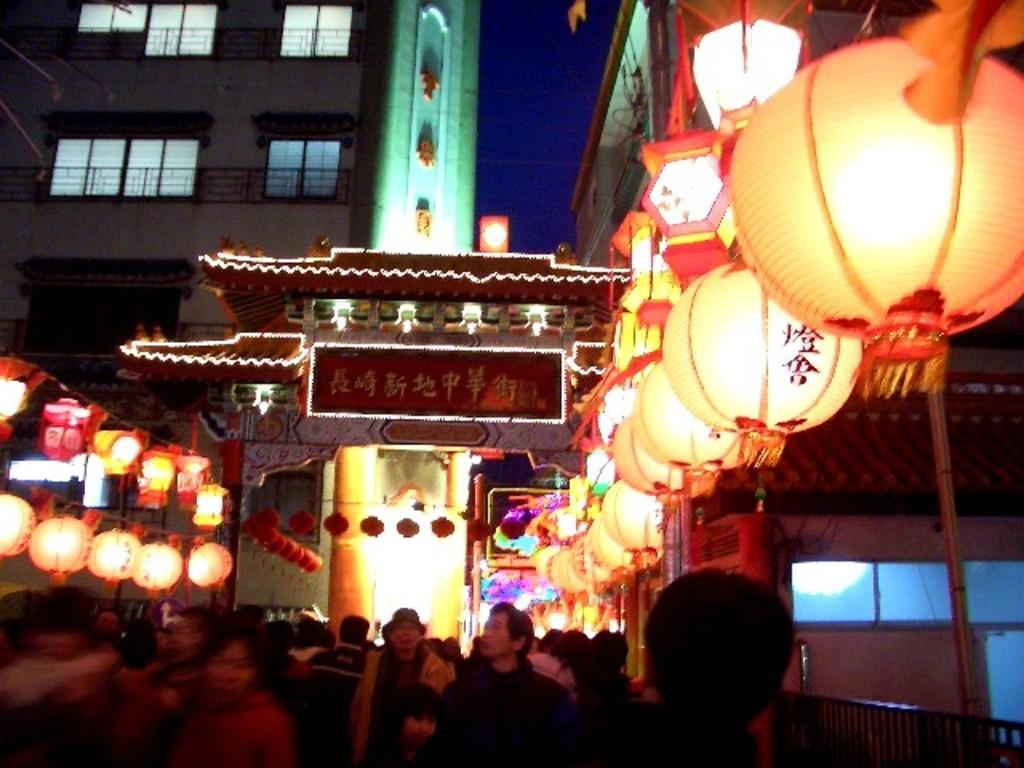What type of structures can be seen in the image? There are buildings in the image. Are there any people present in the image? Yes, there are people standing in the image. What type of lighting is present in the image? There are lanterns and an arch with lighting in the image. Where is the kettle located in the image? There is no kettle present in the image. What route are the people taking in the image? The image does not show the people taking a specific route; they are simply standing. 